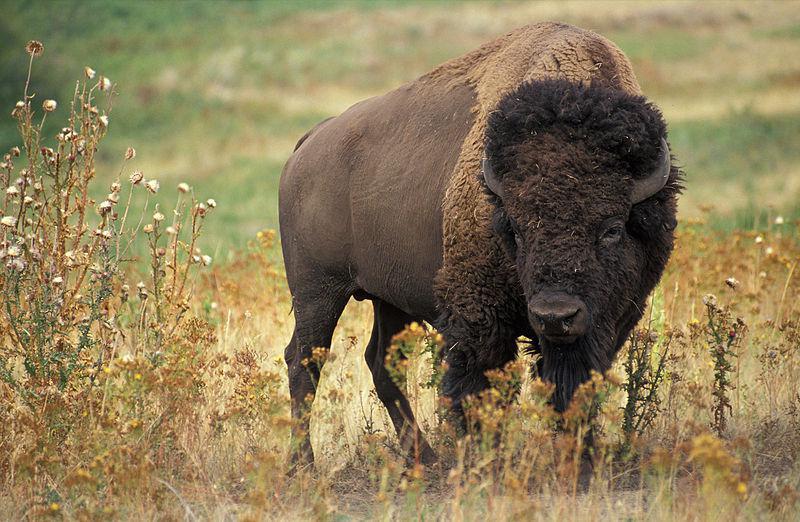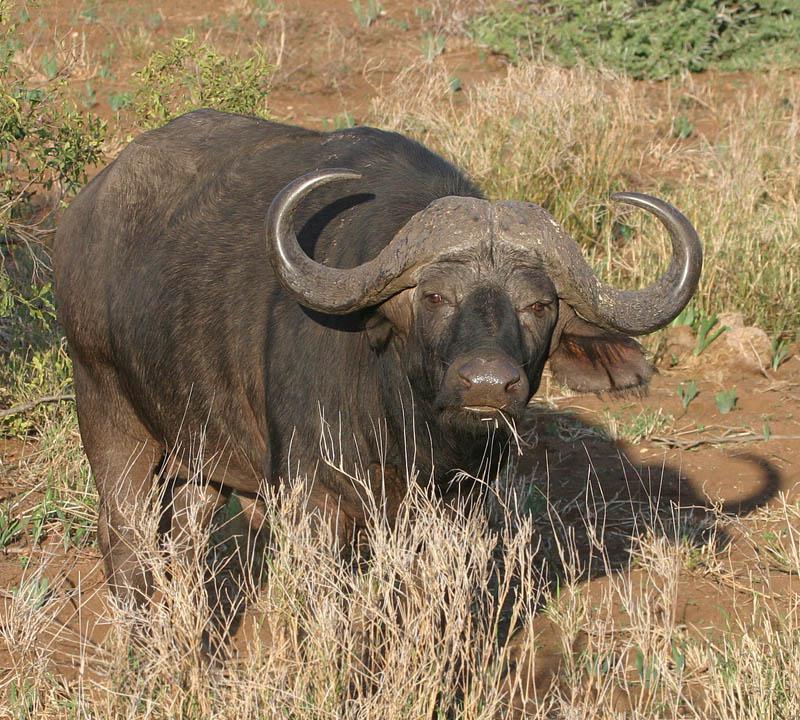The first image is the image on the left, the second image is the image on the right. Examine the images to the left and right. Is the description "At least one image has more than one animal." accurate? Answer yes or no. No. 